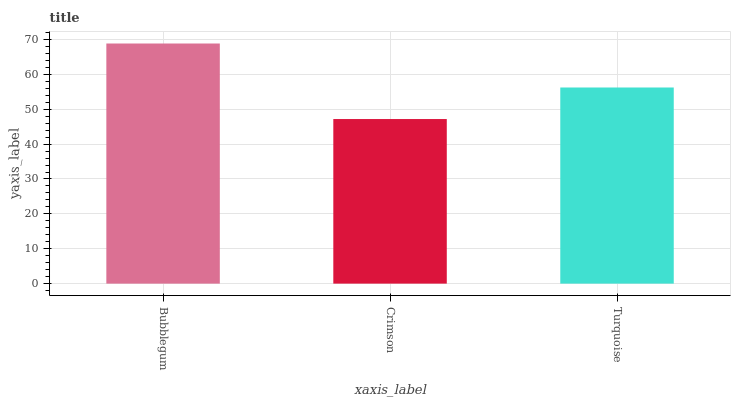Is Crimson the minimum?
Answer yes or no. Yes. Is Bubblegum the maximum?
Answer yes or no. Yes. Is Turquoise the minimum?
Answer yes or no. No. Is Turquoise the maximum?
Answer yes or no. No. Is Turquoise greater than Crimson?
Answer yes or no. Yes. Is Crimson less than Turquoise?
Answer yes or no. Yes. Is Crimson greater than Turquoise?
Answer yes or no. No. Is Turquoise less than Crimson?
Answer yes or no. No. Is Turquoise the high median?
Answer yes or no. Yes. Is Turquoise the low median?
Answer yes or no. Yes. Is Bubblegum the high median?
Answer yes or no. No. Is Crimson the low median?
Answer yes or no. No. 